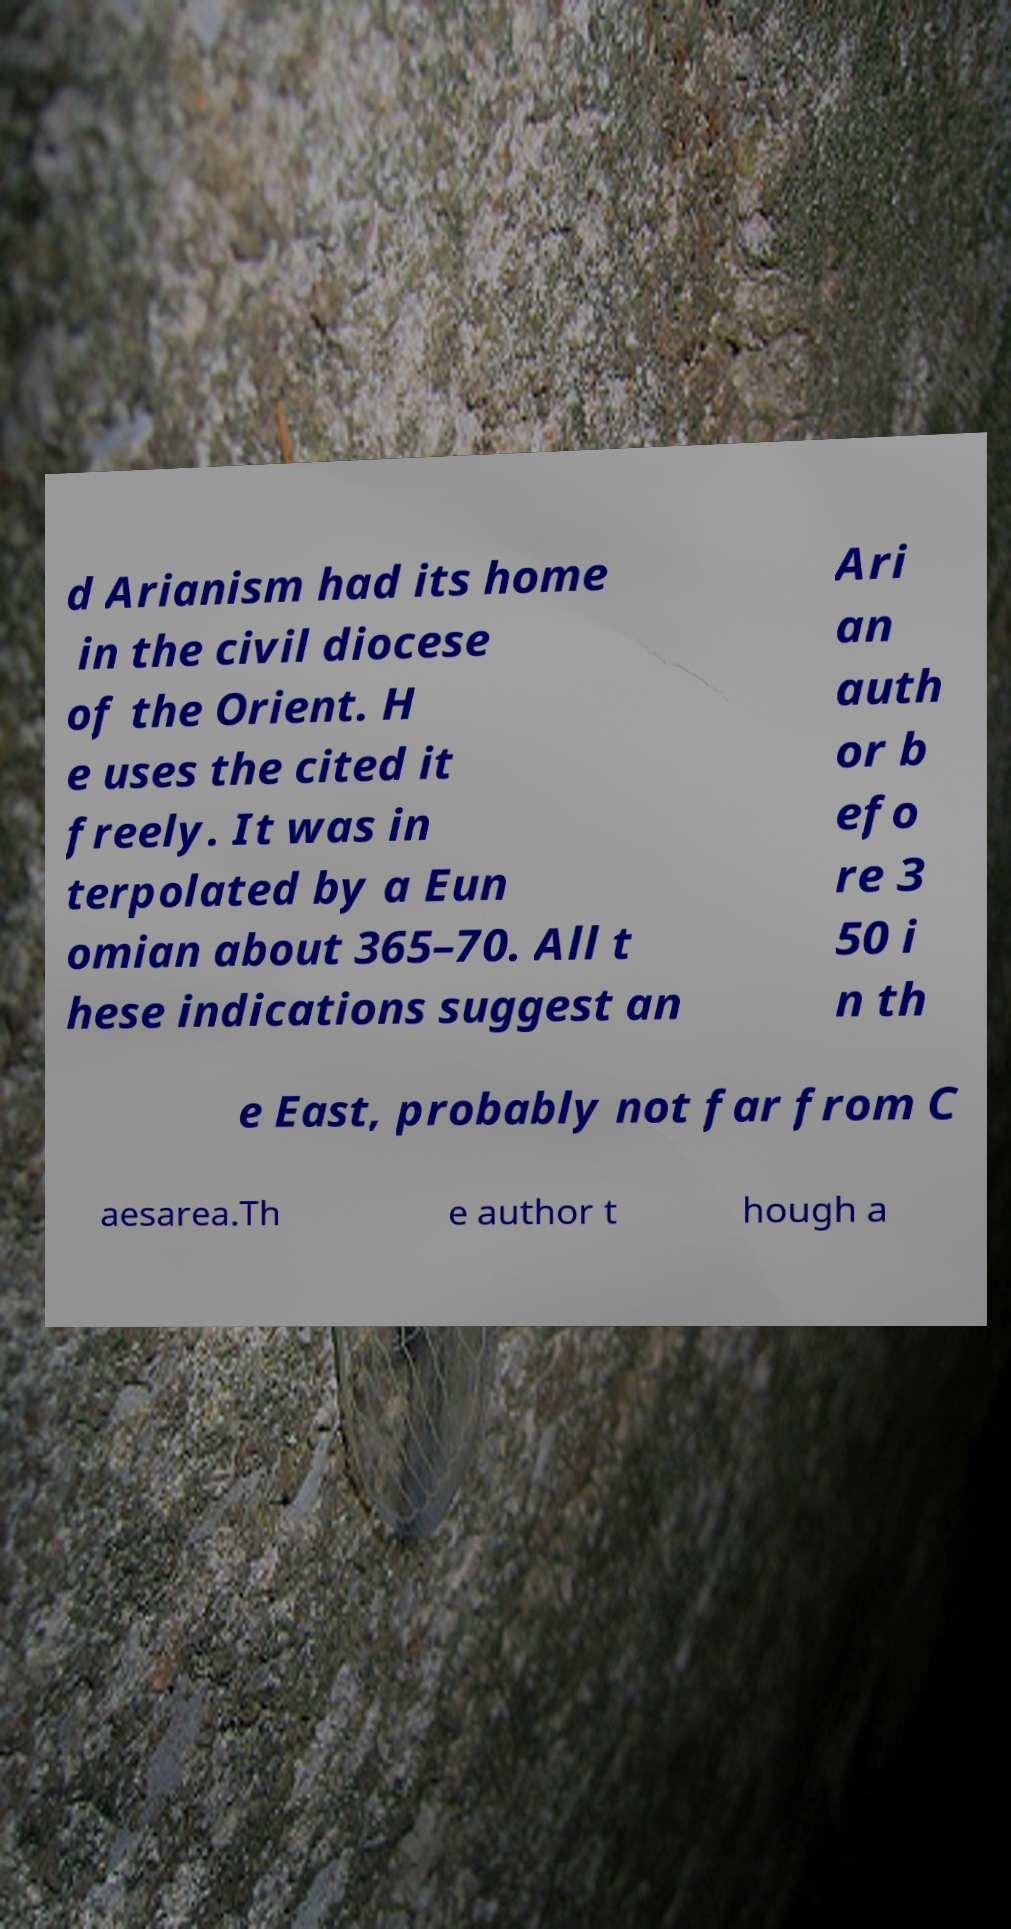Could you extract and type out the text from this image? d Arianism had its home in the civil diocese of the Orient. H e uses the cited it freely. It was in terpolated by a Eun omian about 365–70. All t hese indications suggest an Ari an auth or b efo re 3 50 i n th e East, probably not far from C aesarea.Th e author t hough a 